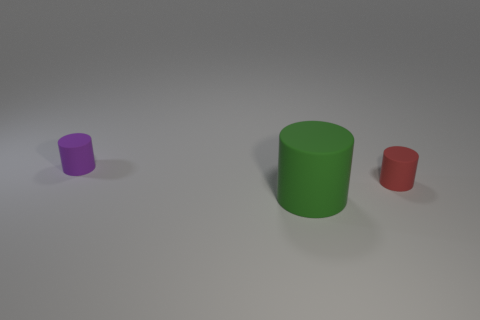What can you infer about the lighting in the scene? The lighting in the scene appears to be soft and diffused, coming from a nondirectional source, as evidenced by the subtle shadows cast by the objects. There are no harsh highlights or strong directional shadows, which would be indicative of direct light sources. This creates a calm and evenly lit scene. Does the lighting suggest anything about the setting? The neutral and nondirectional lighting, combined with the absence of a discernible background, suggests that this scene could be set in a controlled environment, such as a photographic studio, or is a 3D-rendered simulation where the lighting is artistically designed to focus attention solely on the objects, removing distractions from the surroundings. 